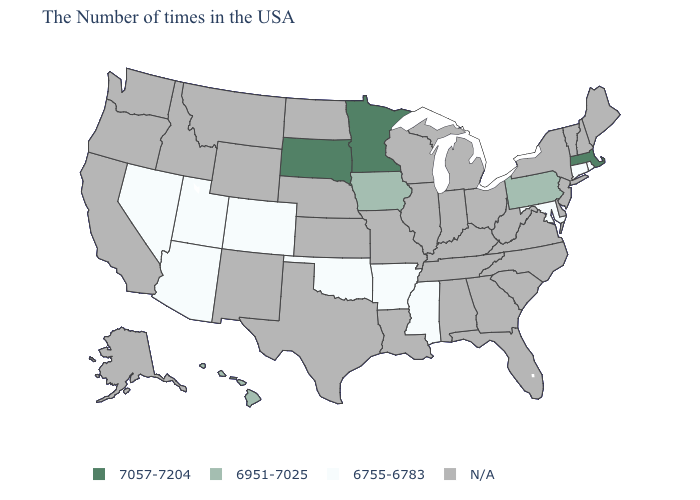What is the value of Utah?
Answer briefly. 6755-6783. Name the states that have a value in the range N/A?
Concise answer only. Maine, New Hampshire, Vermont, New York, New Jersey, Delaware, Virginia, North Carolina, South Carolina, West Virginia, Ohio, Florida, Georgia, Michigan, Kentucky, Indiana, Alabama, Tennessee, Wisconsin, Illinois, Louisiana, Missouri, Kansas, Nebraska, Texas, North Dakota, Wyoming, New Mexico, Montana, Idaho, California, Washington, Oregon, Alaska. What is the value of Wisconsin?
Answer briefly. N/A. What is the lowest value in the USA?
Quick response, please. 6755-6783. What is the lowest value in the South?
Concise answer only. 6755-6783. How many symbols are there in the legend?
Be succinct. 4. Name the states that have a value in the range 6755-6783?
Answer briefly. Rhode Island, Connecticut, Maryland, Mississippi, Arkansas, Oklahoma, Colorado, Utah, Arizona, Nevada. Does Massachusetts have the highest value in the Northeast?
Write a very short answer. Yes. Name the states that have a value in the range 6755-6783?
Answer briefly. Rhode Island, Connecticut, Maryland, Mississippi, Arkansas, Oklahoma, Colorado, Utah, Arizona, Nevada. What is the highest value in the USA?
Short answer required. 7057-7204. What is the highest value in the USA?
Concise answer only. 7057-7204. Which states have the highest value in the USA?
Concise answer only. Massachusetts, Minnesota, South Dakota. Name the states that have a value in the range 6755-6783?
Short answer required. Rhode Island, Connecticut, Maryland, Mississippi, Arkansas, Oklahoma, Colorado, Utah, Arizona, Nevada. Name the states that have a value in the range N/A?
Write a very short answer. Maine, New Hampshire, Vermont, New York, New Jersey, Delaware, Virginia, North Carolina, South Carolina, West Virginia, Ohio, Florida, Georgia, Michigan, Kentucky, Indiana, Alabama, Tennessee, Wisconsin, Illinois, Louisiana, Missouri, Kansas, Nebraska, Texas, North Dakota, Wyoming, New Mexico, Montana, Idaho, California, Washington, Oregon, Alaska. 